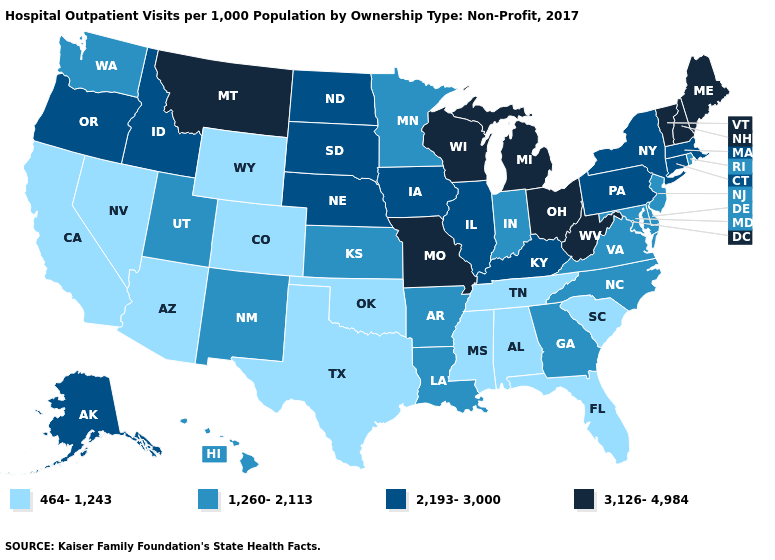Name the states that have a value in the range 2,193-3,000?
Answer briefly. Alaska, Connecticut, Idaho, Illinois, Iowa, Kentucky, Massachusetts, Nebraska, New York, North Dakota, Oregon, Pennsylvania, South Dakota. What is the value of Washington?
Quick response, please. 1,260-2,113. What is the value of Oregon?
Answer briefly. 2,193-3,000. Name the states that have a value in the range 2,193-3,000?
Be succinct. Alaska, Connecticut, Idaho, Illinois, Iowa, Kentucky, Massachusetts, Nebraska, New York, North Dakota, Oregon, Pennsylvania, South Dakota. Name the states that have a value in the range 1,260-2,113?
Answer briefly. Arkansas, Delaware, Georgia, Hawaii, Indiana, Kansas, Louisiana, Maryland, Minnesota, New Jersey, New Mexico, North Carolina, Rhode Island, Utah, Virginia, Washington. What is the lowest value in states that border Maryland?
Short answer required. 1,260-2,113. Does Indiana have the lowest value in the MidWest?
Be succinct. Yes. What is the value of Texas?
Concise answer only. 464-1,243. What is the value of South Carolina?
Keep it brief. 464-1,243. Which states have the highest value in the USA?
Keep it brief. Maine, Michigan, Missouri, Montana, New Hampshire, Ohio, Vermont, West Virginia, Wisconsin. What is the highest value in the West ?
Concise answer only. 3,126-4,984. Does Alabama have the lowest value in the South?
Quick response, please. Yes. What is the value of Vermont?
Write a very short answer. 3,126-4,984. Name the states that have a value in the range 464-1,243?
Short answer required. Alabama, Arizona, California, Colorado, Florida, Mississippi, Nevada, Oklahoma, South Carolina, Tennessee, Texas, Wyoming. Name the states that have a value in the range 2,193-3,000?
Keep it brief. Alaska, Connecticut, Idaho, Illinois, Iowa, Kentucky, Massachusetts, Nebraska, New York, North Dakota, Oregon, Pennsylvania, South Dakota. 